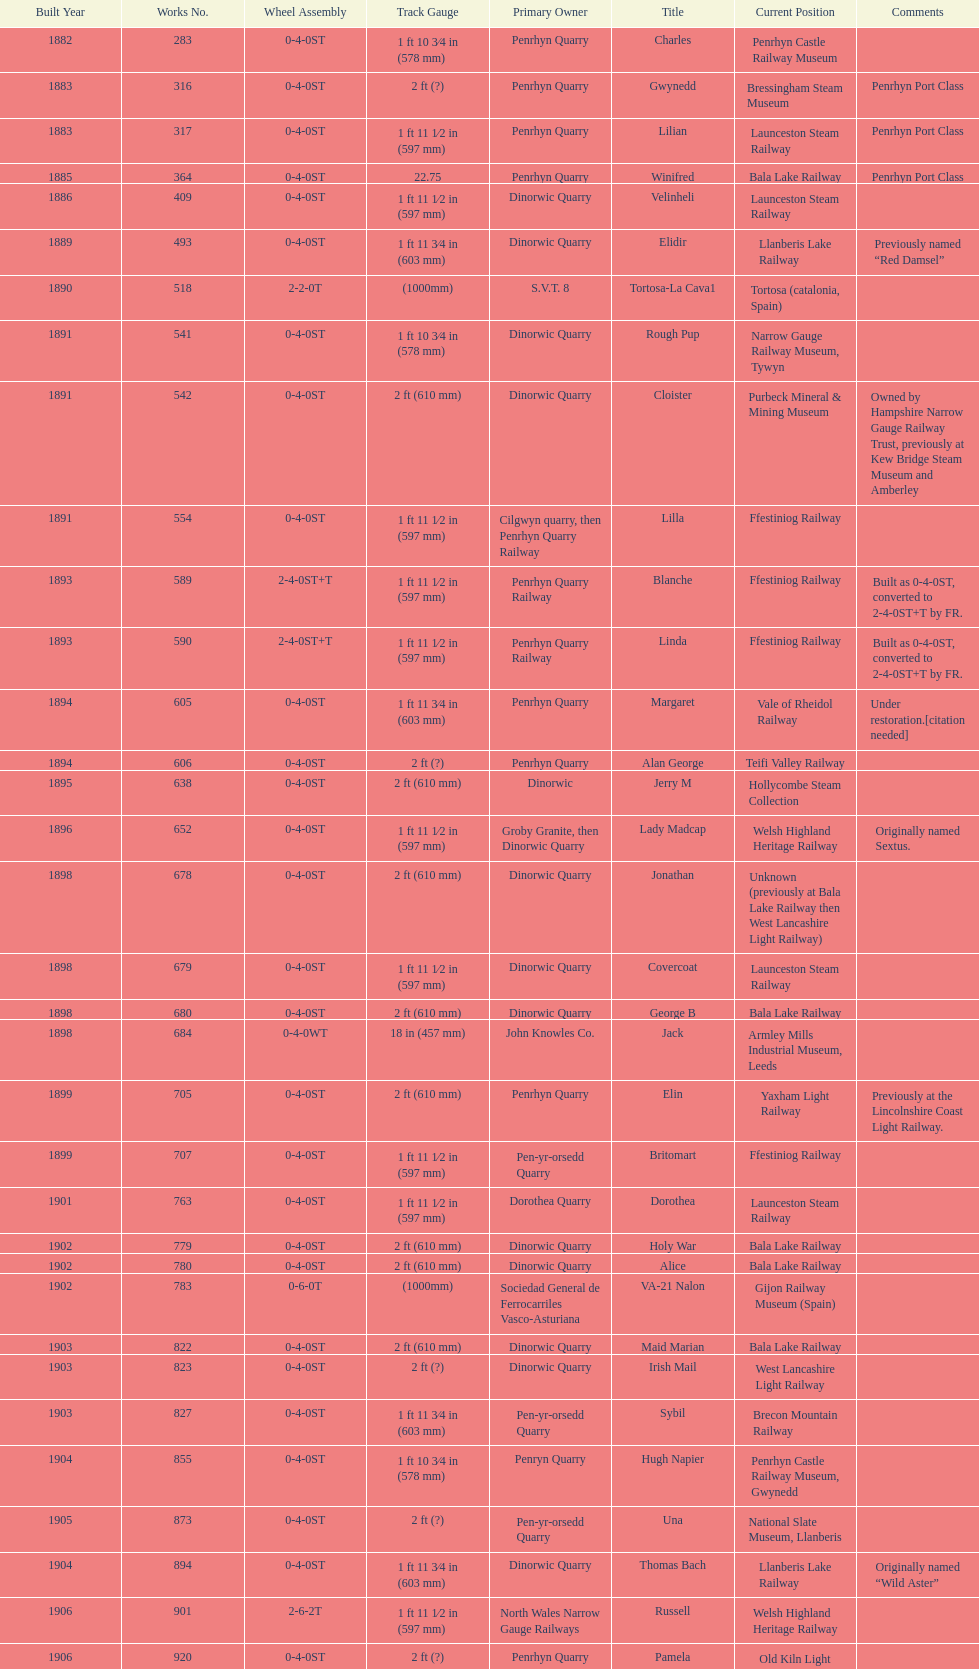Who owned the last locomotive to be built? Trangkil Sugar Mill, Indonesia. 